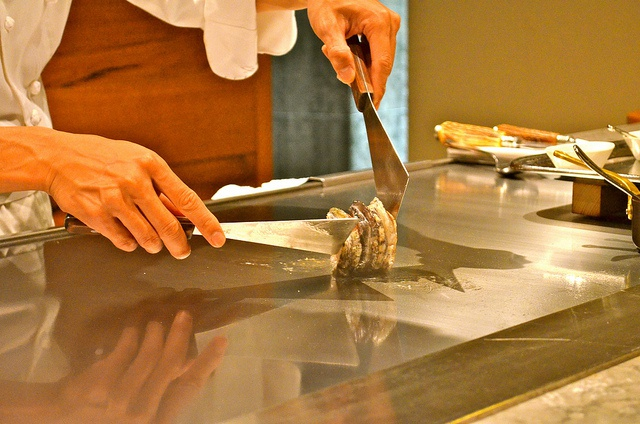Describe the objects in this image and their specific colors. I can see people in tan, orange, and red tones, knife in tan, khaki, lightyellow, and olive tones, knife in tan, brown, maroon, and black tones, knife in tan, gold, orange, and ivory tones, and bowl in tan, beige, khaki, and orange tones in this image. 